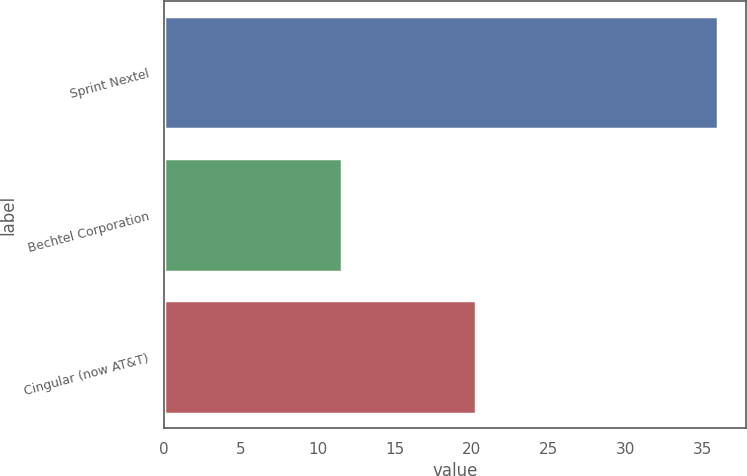<chart> <loc_0><loc_0><loc_500><loc_500><bar_chart><fcel>Sprint Nextel<fcel>Bechtel Corporation<fcel>Cingular (now AT&T)<nl><fcel>36<fcel>11.6<fcel>20.3<nl></chart> 